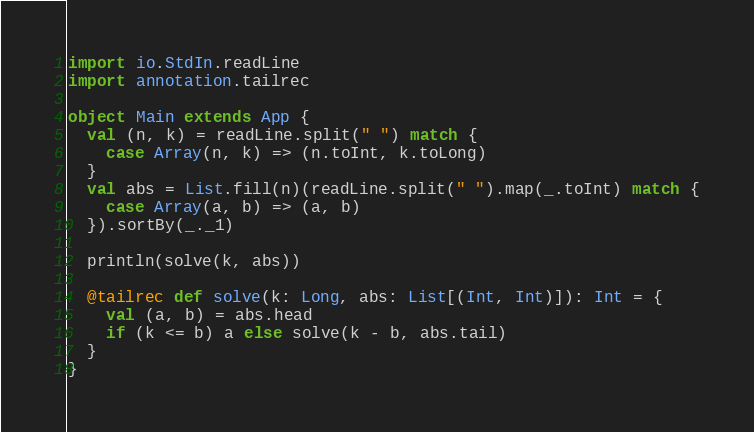Convert code to text. <code><loc_0><loc_0><loc_500><loc_500><_Scala_>import io.StdIn.readLine
import annotation.tailrec

object Main extends App {
  val (n, k) = readLine.split(" ") match {
    case Array(n, k) => (n.toInt, k.toLong)
  }
  val abs = List.fill(n)(readLine.split(" ").map(_.toInt) match {
    case Array(a, b) => (a, b)
  }).sortBy(_._1)

  println(solve(k, abs))

  @tailrec def solve(k: Long, abs: List[(Int, Int)]): Int = {
    val (a, b) = abs.head
    if (k <= b) a else solve(k - b, abs.tail)
  }
}
</code> 